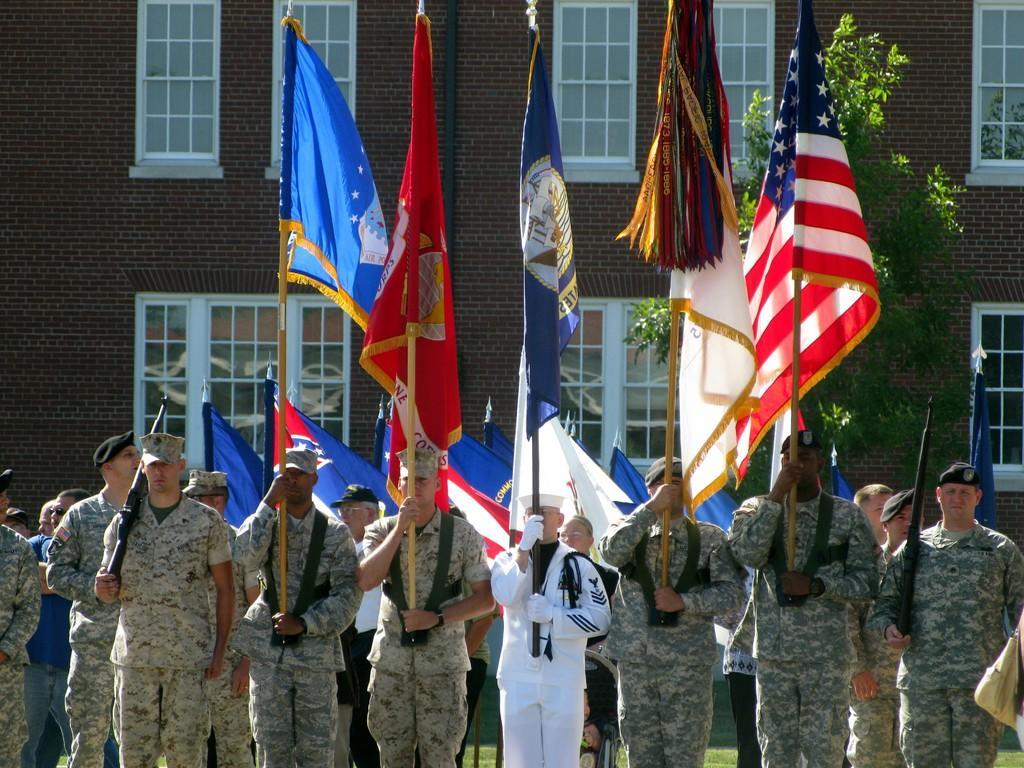Could you give a brief overview of what you see in this image? In this image I can see the group of people are standing and few people are holding flags. I can see the building, windows and trees. 